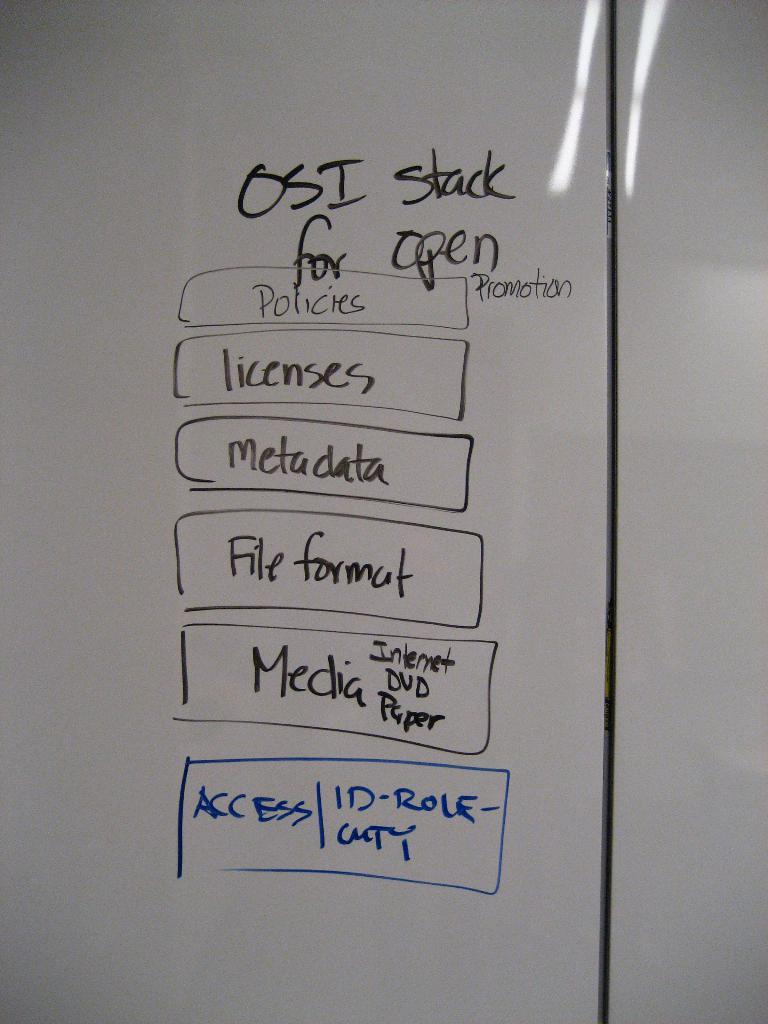<image>
Give a short and clear explanation of the subsequent image. A list on a whiteboard for an OSI stack for open promotion. 